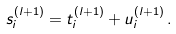Convert formula to latex. <formula><loc_0><loc_0><loc_500><loc_500>s ^ { ( l + 1 ) } _ { i } = t ^ { ( l + 1 ) } _ { i } + u ^ { ( l + 1 ) } _ { i } \, .</formula> 